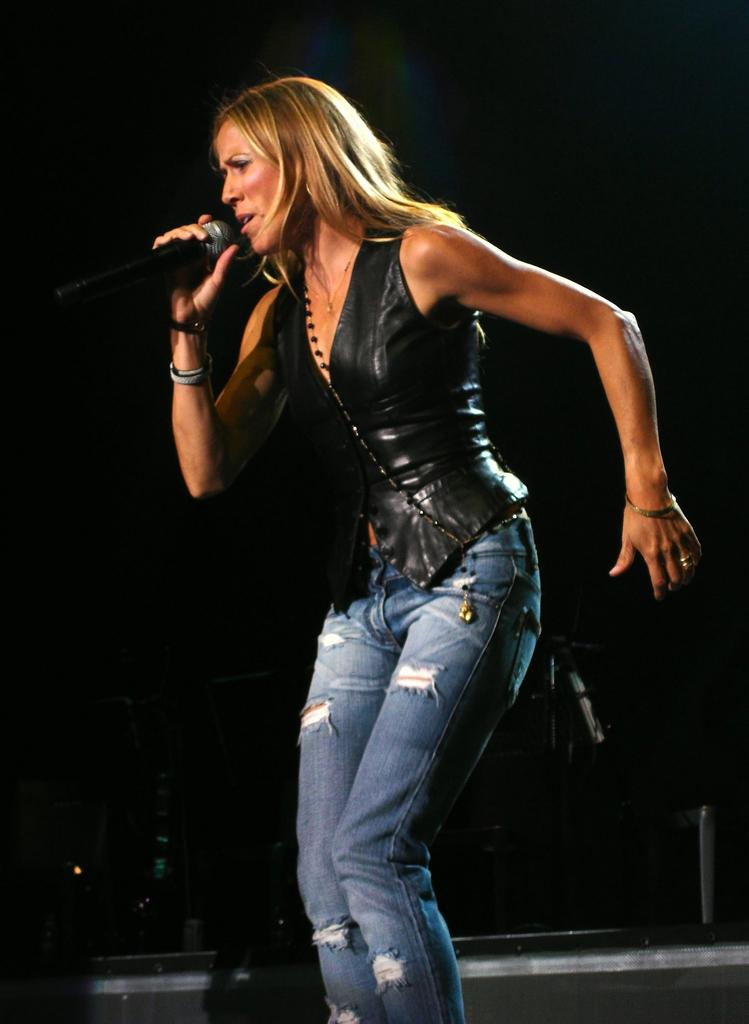Who is the main subject in the image? There is a woman in the image. What is the woman doing in the image? The woman is standing and appears to be singing. What object is the woman holding in the image? The woman is holding a microphone in the image. What is the degree of the woman's smile in the image? The image does not provide information about the degree of the woman's smile, as it does not show her smiling. 